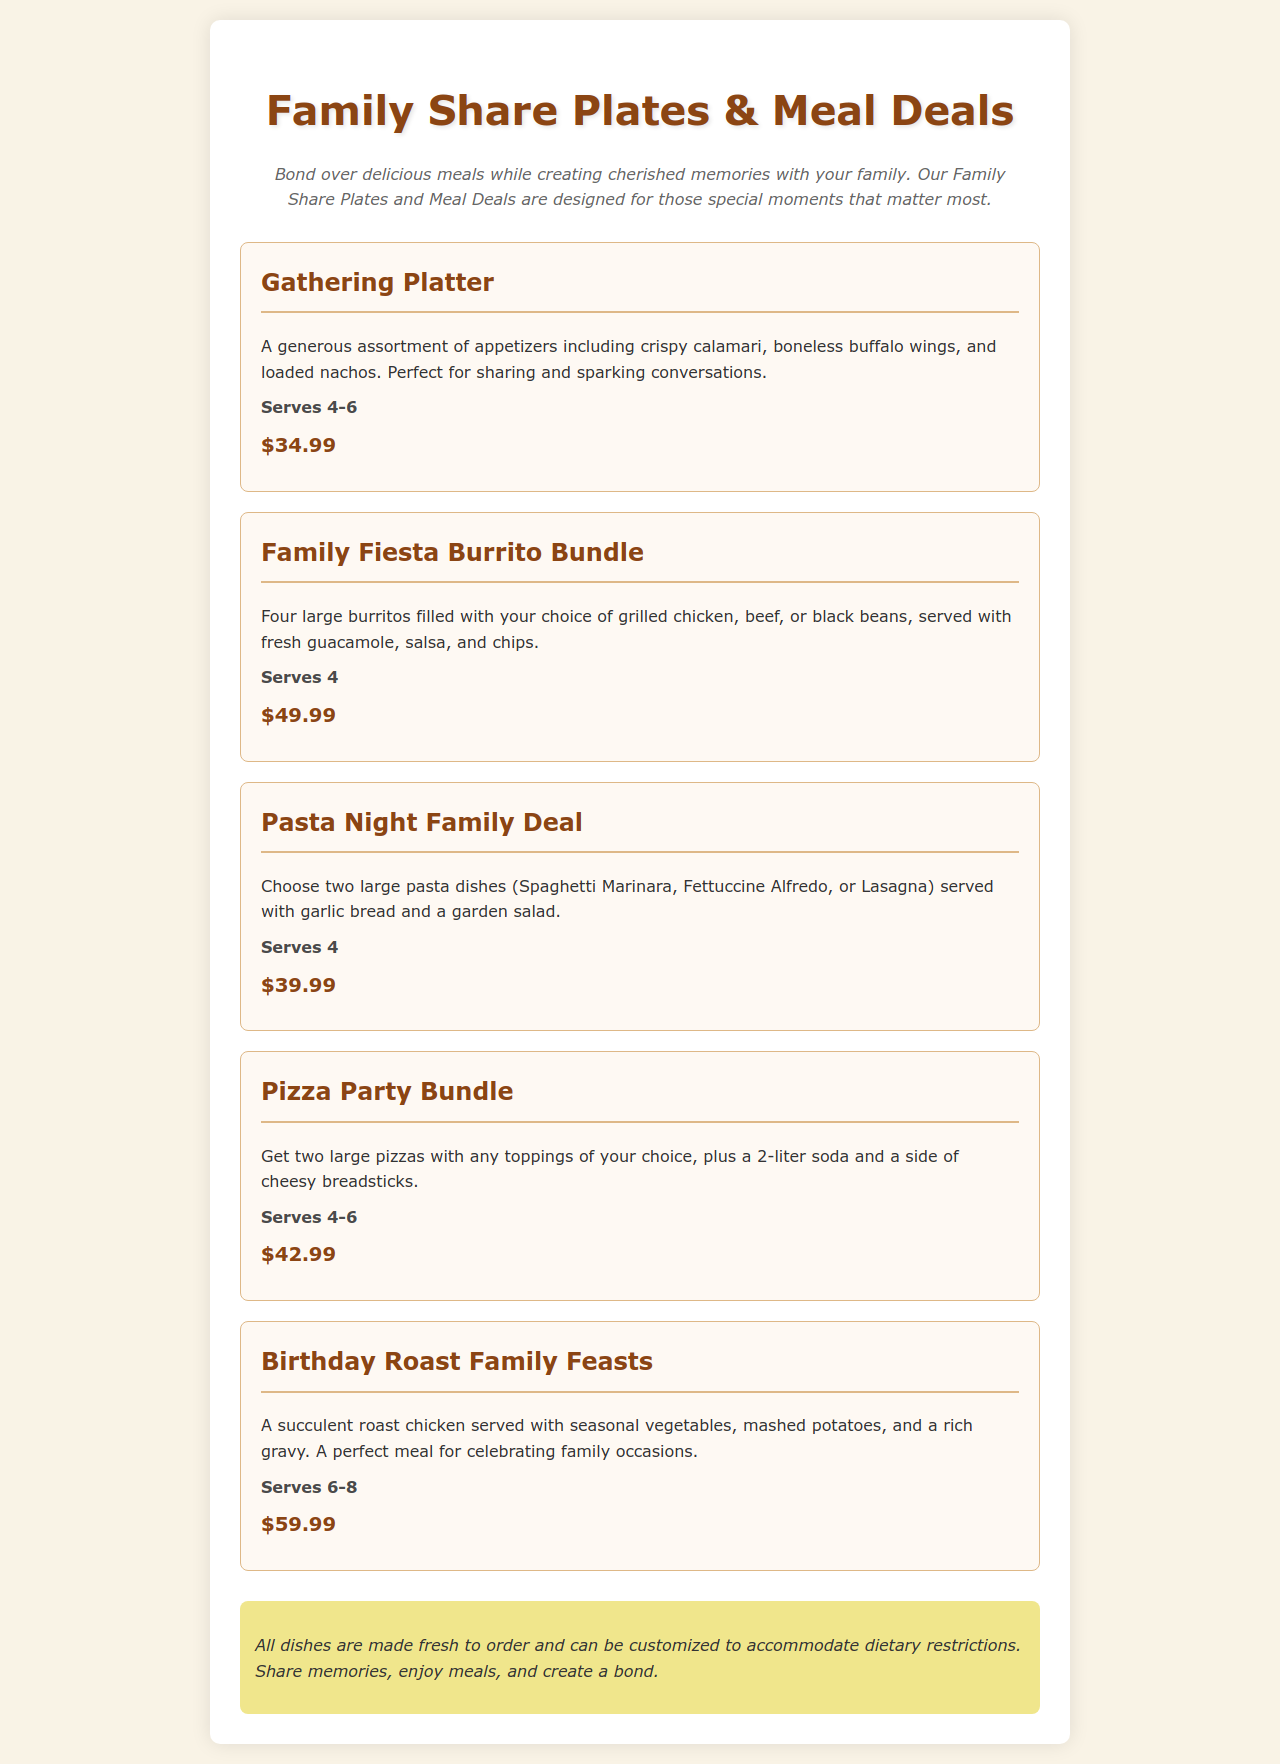What is the price of the Gathering Platter? The price for the Gathering Platter is mentioned in the document as $34.99.
Answer: $34.99 How many people does the Family Fiesta Burrito Bundle serve? The serving size for the Family Fiesta Burrito Bundle is stated as Serves 4 in the document.
Answer: Serves 4 What items are included in the Pizza Party Bundle? The Pizza Party Bundle includes two large pizzas, a 2-liter soda, and a side of cheesy breadsticks.
Answer: Two large pizzas, a 2-liter soda, and a side of cheesy breadsticks What is the serving size for the Birthday Roast Family Feasts? The serving size for the Birthday Roast Family Feasts is written as Serves 6-8 in the document.
Answer: Serves 6-8 What type of deal is the Pasta Night Family Deal? The Pasta Night Family Deal is a meal deal that includes two large pasta dishes with sides.
Answer: Meal deal What is the theme of the document? The document revolves around family meals and sharing food together.
Answer: Family meals and sharing food together What can all dishes accommodate? The document notes that all dishes can be customized to accommodate dietary restrictions.
Answer: Dietary restrictions What is the description at the beginning of the document? The description emphasizes bonding over delicious meals while creating cherished memories.
Answer: Bond over delicious meals while creating cherished memories 